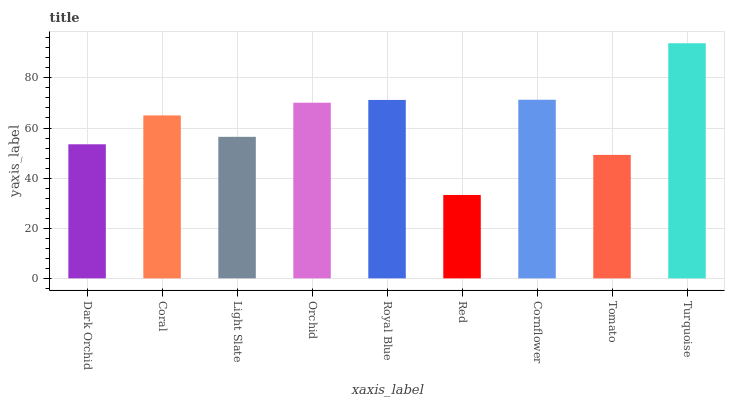Is Coral the minimum?
Answer yes or no. No. Is Coral the maximum?
Answer yes or no. No. Is Coral greater than Dark Orchid?
Answer yes or no. Yes. Is Dark Orchid less than Coral?
Answer yes or no. Yes. Is Dark Orchid greater than Coral?
Answer yes or no. No. Is Coral less than Dark Orchid?
Answer yes or no. No. Is Coral the high median?
Answer yes or no. Yes. Is Coral the low median?
Answer yes or no. Yes. Is Light Slate the high median?
Answer yes or no. No. Is Royal Blue the low median?
Answer yes or no. No. 